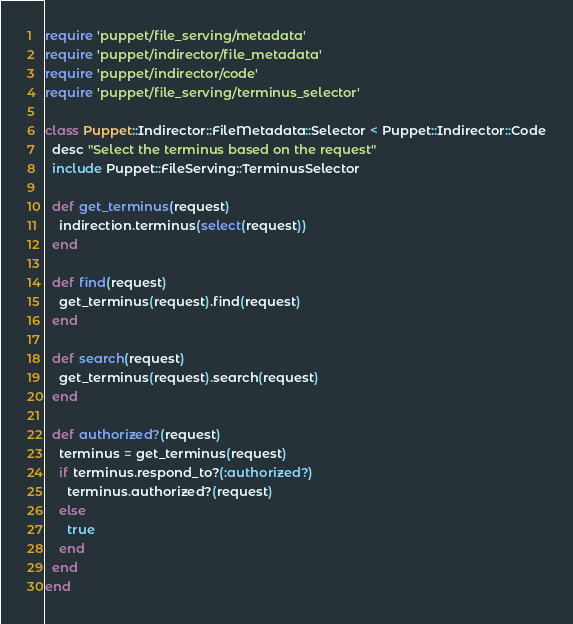Convert code to text. <code><loc_0><loc_0><loc_500><loc_500><_Ruby_>require 'puppet/file_serving/metadata'
require 'puppet/indirector/file_metadata'
require 'puppet/indirector/code'
require 'puppet/file_serving/terminus_selector'

class Puppet::Indirector::FileMetadata::Selector < Puppet::Indirector::Code
  desc "Select the terminus based on the request"
  include Puppet::FileServing::TerminusSelector

  def get_terminus(request)
    indirection.terminus(select(request))
  end

  def find(request)
    get_terminus(request).find(request)
  end

  def search(request)
    get_terminus(request).search(request)
  end

  def authorized?(request)
    terminus = get_terminus(request)
    if terminus.respond_to?(:authorized?)
      terminus.authorized?(request)
    else
      true
    end
  end
end
</code> 